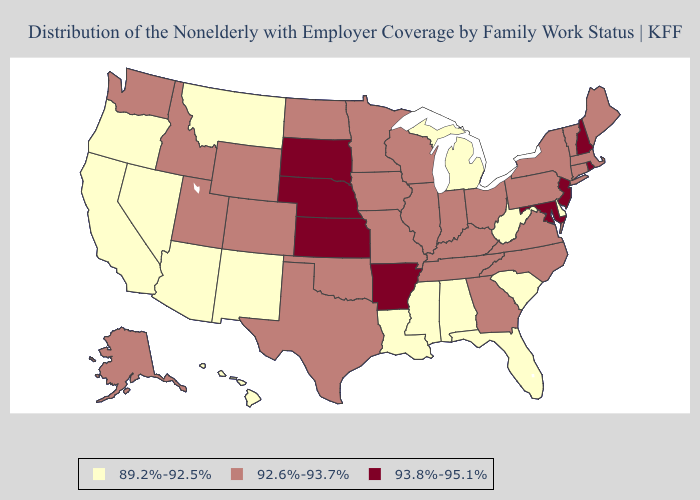Does Alabama have the same value as North Dakota?
Give a very brief answer. No. Name the states that have a value in the range 89.2%-92.5%?
Answer briefly. Alabama, Arizona, California, Delaware, Florida, Hawaii, Louisiana, Michigan, Mississippi, Montana, Nevada, New Mexico, Oregon, South Carolina, West Virginia. What is the value of Colorado?
Write a very short answer. 92.6%-93.7%. Does Rhode Island have the lowest value in the Northeast?
Keep it brief. No. Does Florida have the lowest value in the USA?
Be succinct. Yes. Which states have the lowest value in the USA?
Short answer required. Alabama, Arizona, California, Delaware, Florida, Hawaii, Louisiana, Michigan, Mississippi, Montana, Nevada, New Mexico, Oregon, South Carolina, West Virginia. Name the states that have a value in the range 89.2%-92.5%?
Answer briefly. Alabama, Arizona, California, Delaware, Florida, Hawaii, Louisiana, Michigan, Mississippi, Montana, Nevada, New Mexico, Oregon, South Carolina, West Virginia. Name the states that have a value in the range 93.8%-95.1%?
Give a very brief answer. Arkansas, Kansas, Maryland, Nebraska, New Hampshire, New Jersey, Rhode Island, South Dakota. Does Connecticut have a lower value than Rhode Island?
Give a very brief answer. Yes. Among the states that border Kentucky , which have the lowest value?
Keep it brief. West Virginia. What is the value of Utah?
Short answer required. 92.6%-93.7%. How many symbols are there in the legend?
Be succinct. 3. What is the lowest value in states that border Maine?
Keep it brief. 93.8%-95.1%. What is the lowest value in the MidWest?
Answer briefly. 89.2%-92.5%. What is the value of Florida?
Answer briefly. 89.2%-92.5%. 